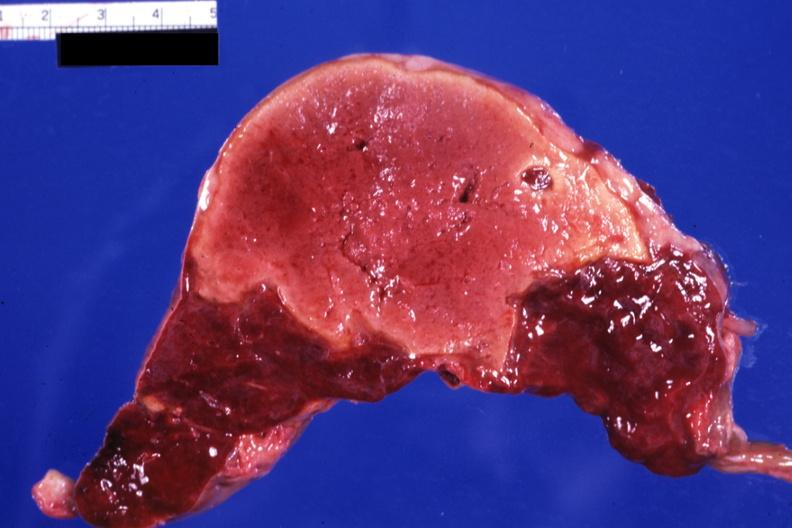s basilar skull fracture present?
Answer the question using a single word or phrase. No 